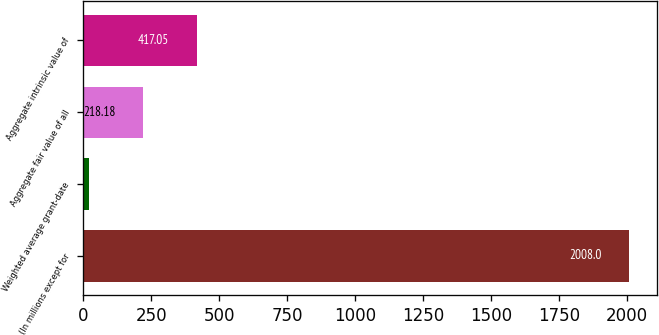Convert chart. <chart><loc_0><loc_0><loc_500><loc_500><bar_chart><fcel>(In millions except for<fcel>Weighted average grant-date<fcel>Aggregate fair value of all<fcel>Aggregate intrinsic value of<nl><fcel>2008<fcel>19.31<fcel>218.18<fcel>417.05<nl></chart> 